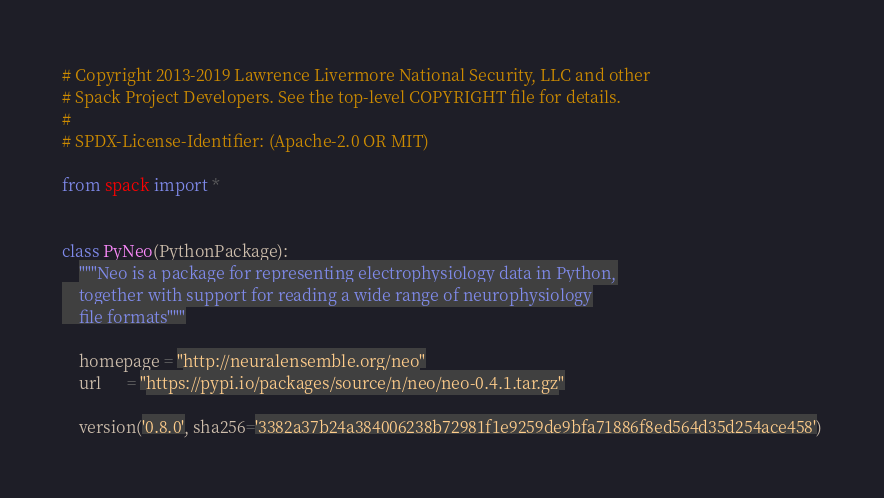Convert code to text. <code><loc_0><loc_0><loc_500><loc_500><_Python_># Copyright 2013-2019 Lawrence Livermore National Security, LLC and other
# Spack Project Developers. See the top-level COPYRIGHT file for details.
#
# SPDX-License-Identifier: (Apache-2.0 OR MIT)

from spack import *


class PyNeo(PythonPackage):
    """Neo is a package for representing electrophysiology data in Python,
    together with support for reading a wide range of neurophysiology
    file formats"""

    homepage = "http://neuralensemble.org/neo"
    url      = "https://pypi.io/packages/source/n/neo/neo-0.4.1.tar.gz"

    version('0.8.0', sha256='3382a37b24a384006238b72981f1e9259de9bfa71886f8ed564d35d254ace458')</code> 